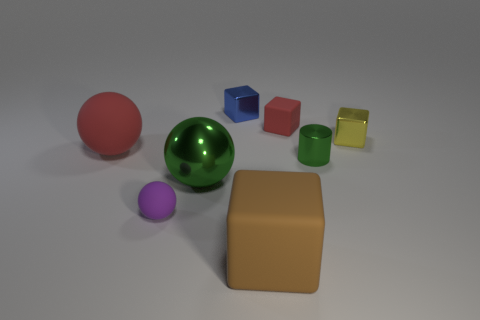Aside from the spheres, what other shapes are visible and what are their colors and apparent textures? Besides the spheres, there are several other geometric shapes present. These include a large, matte-textured cube that's tan in color. In front of this cube, there's a tiny yellow cube with a shiny, metallic sheen. Additionally, there are two smaller cubes, one blue and one red, both with a matte surface. Lastly, there's a small, shiny, green cylinder next to the blue and red cubes. 